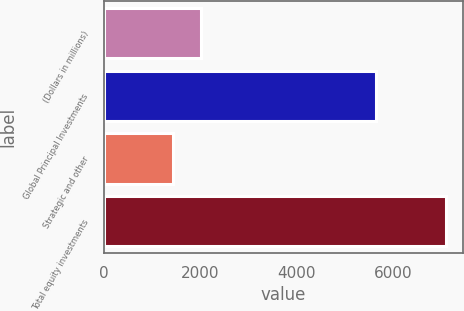Convert chart. <chart><loc_0><loc_0><loc_500><loc_500><bar_chart><fcel>(Dollars in millions)<fcel>Global Principal Investments<fcel>Strategic and other<fcel>Total equity investments<nl><fcel>2011<fcel>5659<fcel>1439<fcel>7098<nl></chart> 